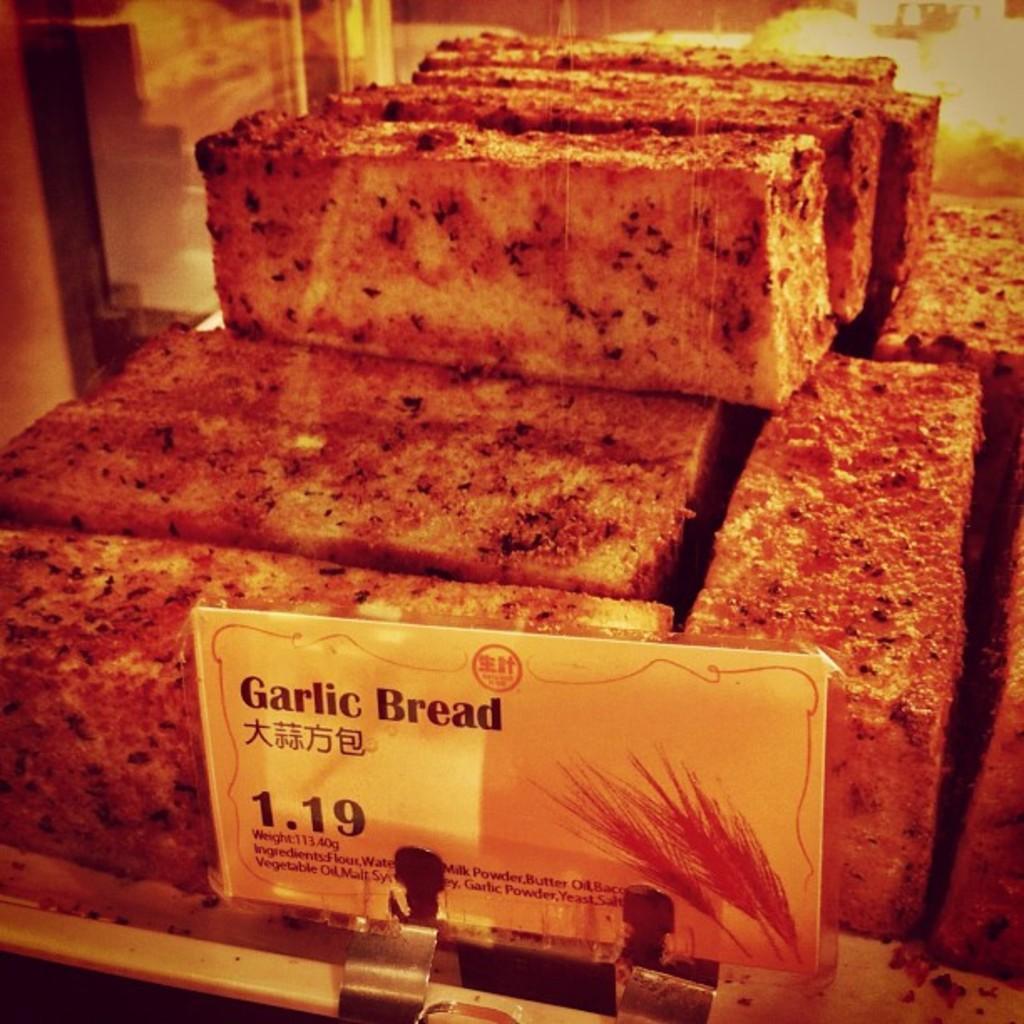In one or two sentences, can you explain what this image depicts? In this image there are so many slices of garlic bread kept on the tray, in front of them there is a price board. 